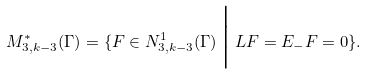Convert formula to latex. <formula><loc_0><loc_0><loc_500><loc_500>M ^ { * } _ { 3 , k - 3 } ( \Gamma ) = \{ F \in N ^ { 1 } _ { 3 , k - 3 } ( \Gamma ) \, \Big | \, L F = E _ { - } F = 0 \} .</formula> 